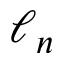Convert formula to latex. <formula><loc_0><loc_0><loc_500><loc_500>\ell _ { n }</formula> 